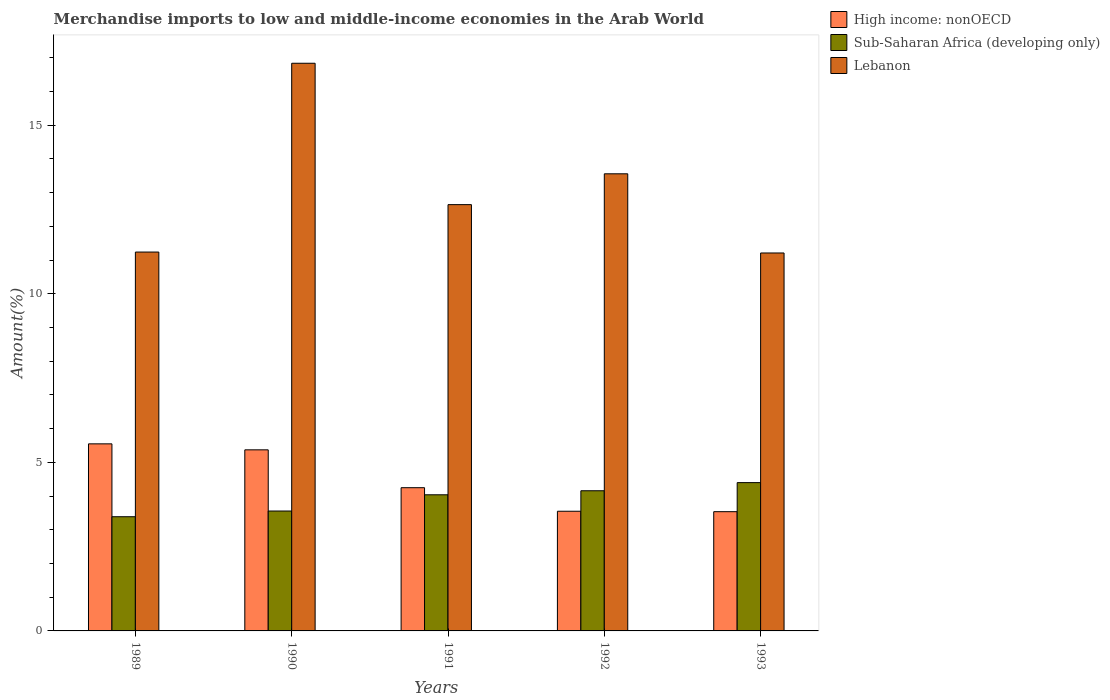How many different coloured bars are there?
Your answer should be very brief. 3. How many groups of bars are there?
Offer a terse response. 5. Are the number of bars per tick equal to the number of legend labels?
Your response must be concise. Yes. How many bars are there on the 3rd tick from the left?
Provide a short and direct response. 3. What is the percentage of amount earned from merchandise imports in High income: nonOECD in 1989?
Ensure brevity in your answer.  5.55. Across all years, what is the maximum percentage of amount earned from merchandise imports in High income: nonOECD?
Provide a short and direct response. 5.55. Across all years, what is the minimum percentage of amount earned from merchandise imports in Sub-Saharan Africa (developing only)?
Your answer should be compact. 3.39. In which year was the percentage of amount earned from merchandise imports in Lebanon maximum?
Ensure brevity in your answer.  1990. In which year was the percentage of amount earned from merchandise imports in High income: nonOECD minimum?
Keep it short and to the point. 1993. What is the total percentage of amount earned from merchandise imports in Lebanon in the graph?
Offer a terse response. 65.5. What is the difference between the percentage of amount earned from merchandise imports in Sub-Saharan Africa (developing only) in 1990 and that in 1993?
Provide a succinct answer. -0.84. What is the difference between the percentage of amount earned from merchandise imports in High income: nonOECD in 1992 and the percentage of amount earned from merchandise imports in Sub-Saharan Africa (developing only) in 1990?
Ensure brevity in your answer.  -0.01. What is the average percentage of amount earned from merchandise imports in High income: nonOECD per year?
Offer a terse response. 4.45. In the year 1993, what is the difference between the percentage of amount earned from merchandise imports in High income: nonOECD and percentage of amount earned from merchandise imports in Sub-Saharan Africa (developing only)?
Keep it short and to the point. -0.86. What is the ratio of the percentage of amount earned from merchandise imports in Lebanon in 1989 to that in 1992?
Your answer should be compact. 0.83. Is the difference between the percentage of amount earned from merchandise imports in High income: nonOECD in 1990 and 1992 greater than the difference between the percentage of amount earned from merchandise imports in Sub-Saharan Africa (developing only) in 1990 and 1992?
Keep it short and to the point. Yes. What is the difference between the highest and the second highest percentage of amount earned from merchandise imports in Sub-Saharan Africa (developing only)?
Ensure brevity in your answer.  0.24. What is the difference between the highest and the lowest percentage of amount earned from merchandise imports in Lebanon?
Give a very brief answer. 5.63. In how many years, is the percentage of amount earned from merchandise imports in High income: nonOECD greater than the average percentage of amount earned from merchandise imports in High income: nonOECD taken over all years?
Your answer should be compact. 2. Is the sum of the percentage of amount earned from merchandise imports in Sub-Saharan Africa (developing only) in 1991 and 1992 greater than the maximum percentage of amount earned from merchandise imports in Lebanon across all years?
Provide a succinct answer. No. What does the 2nd bar from the left in 1993 represents?
Your answer should be very brief. Sub-Saharan Africa (developing only). What does the 1st bar from the right in 1992 represents?
Keep it short and to the point. Lebanon. Is it the case that in every year, the sum of the percentage of amount earned from merchandise imports in High income: nonOECD and percentage of amount earned from merchandise imports in Sub-Saharan Africa (developing only) is greater than the percentage of amount earned from merchandise imports in Lebanon?
Offer a terse response. No. How many bars are there?
Your response must be concise. 15. Are all the bars in the graph horizontal?
Keep it short and to the point. No. How many years are there in the graph?
Your answer should be compact. 5. What is the difference between two consecutive major ticks on the Y-axis?
Offer a terse response. 5. Does the graph contain any zero values?
Give a very brief answer. No. Does the graph contain grids?
Your response must be concise. No. Where does the legend appear in the graph?
Give a very brief answer. Top right. How many legend labels are there?
Provide a short and direct response. 3. How are the legend labels stacked?
Offer a very short reply. Vertical. What is the title of the graph?
Your answer should be very brief. Merchandise imports to low and middle-income economies in the Arab World. What is the label or title of the X-axis?
Provide a short and direct response. Years. What is the label or title of the Y-axis?
Keep it short and to the point. Amount(%). What is the Amount(%) of High income: nonOECD in 1989?
Offer a very short reply. 5.55. What is the Amount(%) of Sub-Saharan Africa (developing only) in 1989?
Make the answer very short. 3.39. What is the Amount(%) of Lebanon in 1989?
Ensure brevity in your answer.  11.24. What is the Amount(%) in High income: nonOECD in 1990?
Give a very brief answer. 5.37. What is the Amount(%) of Sub-Saharan Africa (developing only) in 1990?
Your answer should be very brief. 3.56. What is the Amount(%) in Lebanon in 1990?
Your response must be concise. 16.84. What is the Amount(%) of High income: nonOECD in 1991?
Provide a short and direct response. 4.25. What is the Amount(%) of Sub-Saharan Africa (developing only) in 1991?
Make the answer very short. 4.04. What is the Amount(%) of Lebanon in 1991?
Ensure brevity in your answer.  12.65. What is the Amount(%) in High income: nonOECD in 1992?
Give a very brief answer. 3.55. What is the Amount(%) in Sub-Saharan Africa (developing only) in 1992?
Ensure brevity in your answer.  4.16. What is the Amount(%) of Lebanon in 1992?
Make the answer very short. 13.56. What is the Amount(%) in High income: nonOECD in 1993?
Offer a very short reply. 3.54. What is the Amount(%) in Sub-Saharan Africa (developing only) in 1993?
Provide a succinct answer. 4.4. What is the Amount(%) of Lebanon in 1993?
Your answer should be very brief. 11.21. Across all years, what is the maximum Amount(%) of High income: nonOECD?
Give a very brief answer. 5.55. Across all years, what is the maximum Amount(%) in Sub-Saharan Africa (developing only)?
Your answer should be very brief. 4.4. Across all years, what is the maximum Amount(%) of Lebanon?
Your answer should be compact. 16.84. Across all years, what is the minimum Amount(%) in High income: nonOECD?
Provide a succinct answer. 3.54. Across all years, what is the minimum Amount(%) in Sub-Saharan Africa (developing only)?
Your answer should be compact. 3.39. Across all years, what is the minimum Amount(%) of Lebanon?
Your answer should be very brief. 11.21. What is the total Amount(%) in High income: nonOECD in the graph?
Offer a terse response. 22.26. What is the total Amount(%) of Sub-Saharan Africa (developing only) in the graph?
Make the answer very short. 19.54. What is the total Amount(%) in Lebanon in the graph?
Provide a succinct answer. 65.5. What is the difference between the Amount(%) of High income: nonOECD in 1989 and that in 1990?
Make the answer very short. 0.18. What is the difference between the Amount(%) of Sub-Saharan Africa (developing only) in 1989 and that in 1990?
Offer a very short reply. -0.17. What is the difference between the Amount(%) in Lebanon in 1989 and that in 1990?
Make the answer very short. -5.6. What is the difference between the Amount(%) in High income: nonOECD in 1989 and that in 1991?
Offer a very short reply. 1.3. What is the difference between the Amount(%) of Sub-Saharan Africa (developing only) in 1989 and that in 1991?
Your response must be concise. -0.65. What is the difference between the Amount(%) of Lebanon in 1989 and that in 1991?
Give a very brief answer. -1.41. What is the difference between the Amount(%) of High income: nonOECD in 1989 and that in 1992?
Your response must be concise. 2. What is the difference between the Amount(%) in Sub-Saharan Africa (developing only) in 1989 and that in 1992?
Offer a terse response. -0.77. What is the difference between the Amount(%) of Lebanon in 1989 and that in 1992?
Keep it short and to the point. -2.32. What is the difference between the Amount(%) of High income: nonOECD in 1989 and that in 1993?
Give a very brief answer. 2.01. What is the difference between the Amount(%) in Sub-Saharan Africa (developing only) in 1989 and that in 1993?
Offer a very short reply. -1.01. What is the difference between the Amount(%) of Lebanon in 1989 and that in 1993?
Keep it short and to the point. 0.03. What is the difference between the Amount(%) in High income: nonOECD in 1990 and that in 1991?
Offer a terse response. 1.12. What is the difference between the Amount(%) of Sub-Saharan Africa (developing only) in 1990 and that in 1991?
Your response must be concise. -0.48. What is the difference between the Amount(%) in Lebanon in 1990 and that in 1991?
Your answer should be very brief. 4.19. What is the difference between the Amount(%) of High income: nonOECD in 1990 and that in 1992?
Provide a short and direct response. 1.82. What is the difference between the Amount(%) in Sub-Saharan Africa (developing only) in 1990 and that in 1992?
Provide a short and direct response. -0.6. What is the difference between the Amount(%) in Lebanon in 1990 and that in 1992?
Give a very brief answer. 3.28. What is the difference between the Amount(%) in High income: nonOECD in 1990 and that in 1993?
Provide a succinct answer. 1.83. What is the difference between the Amount(%) in Sub-Saharan Africa (developing only) in 1990 and that in 1993?
Provide a short and direct response. -0.84. What is the difference between the Amount(%) in Lebanon in 1990 and that in 1993?
Ensure brevity in your answer.  5.63. What is the difference between the Amount(%) in High income: nonOECD in 1991 and that in 1992?
Make the answer very short. 0.7. What is the difference between the Amount(%) of Sub-Saharan Africa (developing only) in 1991 and that in 1992?
Provide a short and direct response. -0.12. What is the difference between the Amount(%) of Lebanon in 1991 and that in 1992?
Provide a short and direct response. -0.91. What is the difference between the Amount(%) in High income: nonOECD in 1991 and that in 1993?
Provide a succinct answer. 0.71. What is the difference between the Amount(%) in Sub-Saharan Africa (developing only) in 1991 and that in 1993?
Keep it short and to the point. -0.36. What is the difference between the Amount(%) of Lebanon in 1991 and that in 1993?
Provide a succinct answer. 1.43. What is the difference between the Amount(%) of High income: nonOECD in 1992 and that in 1993?
Keep it short and to the point. 0.01. What is the difference between the Amount(%) in Sub-Saharan Africa (developing only) in 1992 and that in 1993?
Provide a short and direct response. -0.24. What is the difference between the Amount(%) in Lebanon in 1992 and that in 1993?
Give a very brief answer. 2.35. What is the difference between the Amount(%) of High income: nonOECD in 1989 and the Amount(%) of Sub-Saharan Africa (developing only) in 1990?
Your response must be concise. 1.99. What is the difference between the Amount(%) in High income: nonOECD in 1989 and the Amount(%) in Lebanon in 1990?
Provide a succinct answer. -11.29. What is the difference between the Amount(%) of Sub-Saharan Africa (developing only) in 1989 and the Amount(%) of Lebanon in 1990?
Provide a short and direct response. -13.45. What is the difference between the Amount(%) in High income: nonOECD in 1989 and the Amount(%) in Sub-Saharan Africa (developing only) in 1991?
Give a very brief answer. 1.51. What is the difference between the Amount(%) in High income: nonOECD in 1989 and the Amount(%) in Lebanon in 1991?
Your answer should be very brief. -7.1. What is the difference between the Amount(%) of Sub-Saharan Africa (developing only) in 1989 and the Amount(%) of Lebanon in 1991?
Give a very brief answer. -9.26. What is the difference between the Amount(%) of High income: nonOECD in 1989 and the Amount(%) of Sub-Saharan Africa (developing only) in 1992?
Provide a succinct answer. 1.39. What is the difference between the Amount(%) of High income: nonOECD in 1989 and the Amount(%) of Lebanon in 1992?
Your answer should be compact. -8.01. What is the difference between the Amount(%) in Sub-Saharan Africa (developing only) in 1989 and the Amount(%) in Lebanon in 1992?
Your answer should be compact. -10.17. What is the difference between the Amount(%) in High income: nonOECD in 1989 and the Amount(%) in Sub-Saharan Africa (developing only) in 1993?
Ensure brevity in your answer.  1.15. What is the difference between the Amount(%) of High income: nonOECD in 1989 and the Amount(%) of Lebanon in 1993?
Keep it short and to the point. -5.66. What is the difference between the Amount(%) in Sub-Saharan Africa (developing only) in 1989 and the Amount(%) in Lebanon in 1993?
Provide a succinct answer. -7.82. What is the difference between the Amount(%) in High income: nonOECD in 1990 and the Amount(%) in Sub-Saharan Africa (developing only) in 1991?
Give a very brief answer. 1.33. What is the difference between the Amount(%) in High income: nonOECD in 1990 and the Amount(%) in Lebanon in 1991?
Make the answer very short. -7.27. What is the difference between the Amount(%) of Sub-Saharan Africa (developing only) in 1990 and the Amount(%) of Lebanon in 1991?
Keep it short and to the point. -9.09. What is the difference between the Amount(%) of High income: nonOECD in 1990 and the Amount(%) of Sub-Saharan Africa (developing only) in 1992?
Keep it short and to the point. 1.21. What is the difference between the Amount(%) of High income: nonOECD in 1990 and the Amount(%) of Lebanon in 1992?
Provide a short and direct response. -8.19. What is the difference between the Amount(%) of Sub-Saharan Africa (developing only) in 1990 and the Amount(%) of Lebanon in 1992?
Make the answer very short. -10. What is the difference between the Amount(%) in High income: nonOECD in 1990 and the Amount(%) in Sub-Saharan Africa (developing only) in 1993?
Provide a succinct answer. 0.97. What is the difference between the Amount(%) in High income: nonOECD in 1990 and the Amount(%) in Lebanon in 1993?
Provide a short and direct response. -5.84. What is the difference between the Amount(%) of Sub-Saharan Africa (developing only) in 1990 and the Amount(%) of Lebanon in 1993?
Keep it short and to the point. -7.66. What is the difference between the Amount(%) in High income: nonOECD in 1991 and the Amount(%) in Sub-Saharan Africa (developing only) in 1992?
Provide a short and direct response. 0.09. What is the difference between the Amount(%) of High income: nonOECD in 1991 and the Amount(%) of Lebanon in 1992?
Provide a succinct answer. -9.31. What is the difference between the Amount(%) of Sub-Saharan Africa (developing only) in 1991 and the Amount(%) of Lebanon in 1992?
Ensure brevity in your answer.  -9.52. What is the difference between the Amount(%) in High income: nonOECD in 1991 and the Amount(%) in Sub-Saharan Africa (developing only) in 1993?
Your response must be concise. -0.15. What is the difference between the Amount(%) of High income: nonOECD in 1991 and the Amount(%) of Lebanon in 1993?
Offer a terse response. -6.96. What is the difference between the Amount(%) of Sub-Saharan Africa (developing only) in 1991 and the Amount(%) of Lebanon in 1993?
Your answer should be very brief. -7.17. What is the difference between the Amount(%) in High income: nonOECD in 1992 and the Amount(%) in Sub-Saharan Africa (developing only) in 1993?
Provide a succinct answer. -0.85. What is the difference between the Amount(%) of High income: nonOECD in 1992 and the Amount(%) of Lebanon in 1993?
Keep it short and to the point. -7.66. What is the difference between the Amount(%) in Sub-Saharan Africa (developing only) in 1992 and the Amount(%) in Lebanon in 1993?
Make the answer very short. -7.05. What is the average Amount(%) of High income: nonOECD per year?
Provide a succinct answer. 4.45. What is the average Amount(%) of Sub-Saharan Africa (developing only) per year?
Keep it short and to the point. 3.91. What is the average Amount(%) of Lebanon per year?
Offer a terse response. 13.1. In the year 1989, what is the difference between the Amount(%) in High income: nonOECD and Amount(%) in Sub-Saharan Africa (developing only)?
Keep it short and to the point. 2.16. In the year 1989, what is the difference between the Amount(%) in High income: nonOECD and Amount(%) in Lebanon?
Your answer should be compact. -5.69. In the year 1989, what is the difference between the Amount(%) of Sub-Saharan Africa (developing only) and Amount(%) of Lebanon?
Keep it short and to the point. -7.85. In the year 1990, what is the difference between the Amount(%) of High income: nonOECD and Amount(%) of Sub-Saharan Africa (developing only)?
Make the answer very short. 1.82. In the year 1990, what is the difference between the Amount(%) in High income: nonOECD and Amount(%) in Lebanon?
Keep it short and to the point. -11.47. In the year 1990, what is the difference between the Amount(%) of Sub-Saharan Africa (developing only) and Amount(%) of Lebanon?
Provide a short and direct response. -13.28. In the year 1991, what is the difference between the Amount(%) of High income: nonOECD and Amount(%) of Sub-Saharan Africa (developing only)?
Your response must be concise. 0.21. In the year 1991, what is the difference between the Amount(%) in High income: nonOECD and Amount(%) in Lebanon?
Your answer should be very brief. -8.4. In the year 1991, what is the difference between the Amount(%) of Sub-Saharan Africa (developing only) and Amount(%) of Lebanon?
Make the answer very short. -8.61. In the year 1992, what is the difference between the Amount(%) in High income: nonOECD and Amount(%) in Sub-Saharan Africa (developing only)?
Your response must be concise. -0.61. In the year 1992, what is the difference between the Amount(%) in High income: nonOECD and Amount(%) in Lebanon?
Ensure brevity in your answer.  -10.01. In the year 1992, what is the difference between the Amount(%) in Sub-Saharan Africa (developing only) and Amount(%) in Lebanon?
Ensure brevity in your answer.  -9.4. In the year 1993, what is the difference between the Amount(%) in High income: nonOECD and Amount(%) in Sub-Saharan Africa (developing only)?
Give a very brief answer. -0.86. In the year 1993, what is the difference between the Amount(%) of High income: nonOECD and Amount(%) of Lebanon?
Offer a terse response. -7.67. In the year 1993, what is the difference between the Amount(%) in Sub-Saharan Africa (developing only) and Amount(%) in Lebanon?
Offer a very short reply. -6.81. What is the ratio of the Amount(%) of High income: nonOECD in 1989 to that in 1990?
Your answer should be compact. 1.03. What is the ratio of the Amount(%) in Sub-Saharan Africa (developing only) in 1989 to that in 1990?
Offer a terse response. 0.95. What is the ratio of the Amount(%) in Lebanon in 1989 to that in 1990?
Offer a terse response. 0.67. What is the ratio of the Amount(%) of High income: nonOECD in 1989 to that in 1991?
Give a very brief answer. 1.31. What is the ratio of the Amount(%) of Sub-Saharan Africa (developing only) in 1989 to that in 1991?
Your answer should be very brief. 0.84. What is the ratio of the Amount(%) of Lebanon in 1989 to that in 1991?
Offer a terse response. 0.89. What is the ratio of the Amount(%) of High income: nonOECD in 1989 to that in 1992?
Provide a short and direct response. 1.56. What is the ratio of the Amount(%) of Sub-Saharan Africa (developing only) in 1989 to that in 1992?
Ensure brevity in your answer.  0.81. What is the ratio of the Amount(%) in Lebanon in 1989 to that in 1992?
Offer a very short reply. 0.83. What is the ratio of the Amount(%) in High income: nonOECD in 1989 to that in 1993?
Offer a terse response. 1.57. What is the ratio of the Amount(%) in Sub-Saharan Africa (developing only) in 1989 to that in 1993?
Give a very brief answer. 0.77. What is the ratio of the Amount(%) in Lebanon in 1989 to that in 1993?
Offer a terse response. 1. What is the ratio of the Amount(%) of High income: nonOECD in 1990 to that in 1991?
Keep it short and to the point. 1.26. What is the ratio of the Amount(%) of Sub-Saharan Africa (developing only) in 1990 to that in 1991?
Keep it short and to the point. 0.88. What is the ratio of the Amount(%) in Lebanon in 1990 to that in 1991?
Provide a succinct answer. 1.33. What is the ratio of the Amount(%) in High income: nonOECD in 1990 to that in 1992?
Your answer should be compact. 1.51. What is the ratio of the Amount(%) of Sub-Saharan Africa (developing only) in 1990 to that in 1992?
Provide a short and direct response. 0.86. What is the ratio of the Amount(%) of Lebanon in 1990 to that in 1992?
Offer a very short reply. 1.24. What is the ratio of the Amount(%) of High income: nonOECD in 1990 to that in 1993?
Provide a succinct answer. 1.52. What is the ratio of the Amount(%) in Sub-Saharan Africa (developing only) in 1990 to that in 1993?
Make the answer very short. 0.81. What is the ratio of the Amount(%) in Lebanon in 1990 to that in 1993?
Your response must be concise. 1.5. What is the ratio of the Amount(%) in High income: nonOECD in 1991 to that in 1992?
Your answer should be very brief. 1.2. What is the ratio of the Amount(%) of Sub-Saharan Africa (developing only) in 1991 to that in 1992?
Provide a succinct answer. 0.97. What is the ratio of the Amount(%) in Lebanon in 1991 to that in 1992?
Provide a short and direct response. 0.93. What is the ratio of the Amount(%) in High income: nonOECD in 1991 to that in 1993?
Your response must be concise. 1.2. What is the ratio of the Amount(%) of Sub-Saharan Africa (developing only) in 1991 to that in 1993?
Provide a succinct answer. 0.92. What is the ratio of the Amount(%) in Lebanon in 1991 to that in 1993?
Ensure brevity in your answer.  1.13. What is the ratio of the Amount(%) in High income: nonOECD in 1992 to that in 1993?
Your answer should be very brief. 1. What is the ratio of the Amount(%) in Sub-Saharan Africa (developing only) in 1992 to that in 1993?
Keep it short and to the point. 0.95. What is the ratio of the Amount(%) in Lebanon in 1992 to that in 1993?
Give a very brief answer. 1.21. What is the difference between the highest and the second highest Amount(%) in High income: nonOECD?
Keep it short and to the point. 0.18. What is the difference between the highest and the second highest Amount(%) in Sub-Saharan Africa (developing only)?
Your answer should be compact. 0.24. What is the difference between the highest and the second highest Amount(%) of Lebanon?
Give a very brief answer. 3.28. What is the difference between the highest and the lowest Amount(%) of High income: nonOECD?
Your response must be concise. 2.01. What is the difference between the highest and the lowest Amount(%) in Sub-Saharan Africa (developing only)?
Provide a short and direct response. 1.01. What is the difference between the highest and the lowest Amount(%) in Lebanon?
Offer a very short reply. 5.63. 